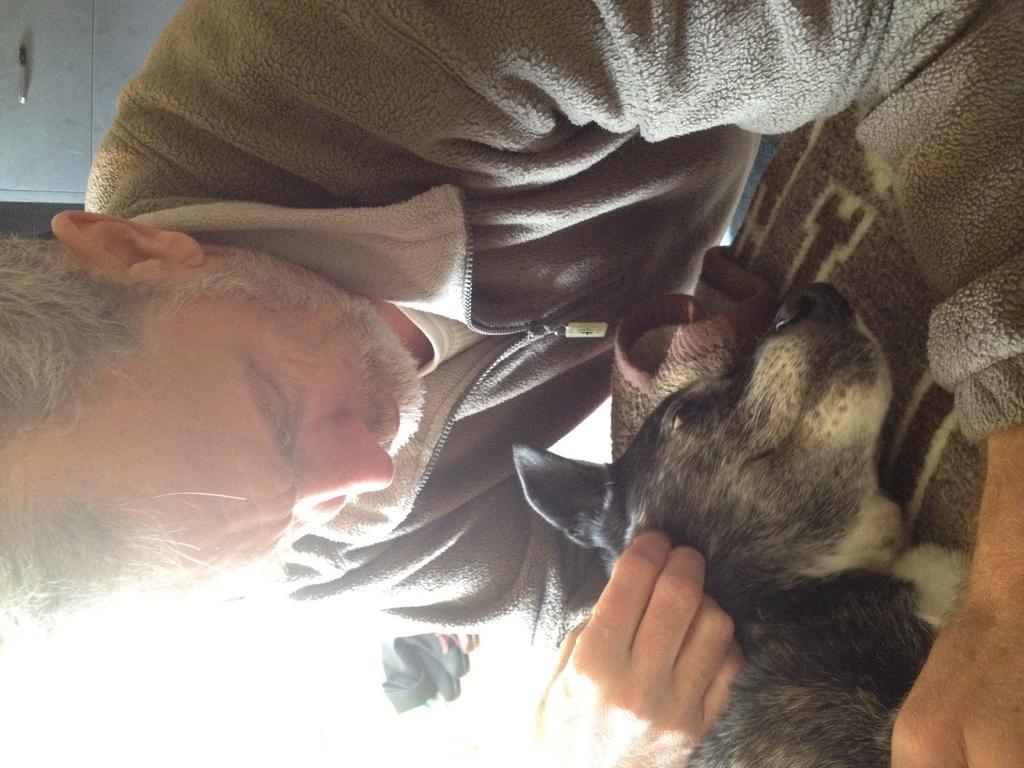Describe this image in one or two sentences. In the picture I can see a person wearing a sweater is pampering the dog which is lying on the surface. In the background, we can see the cupboard. 